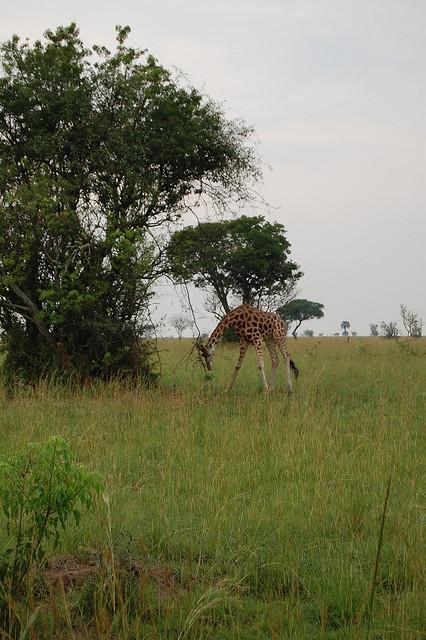What animal is this?
Keep it brief. Giraffe. How many animals can be seen?
Keep it brief. 1. What color is the grass?
Short answer required. Green. Is the giraffe eating?
Answer briefly. Yes. Is this what you would see in a typical American backyard?
Keep it brief. No. What are the giraffes doing?
Quick response, please. Eating. What is the name of the plant in the foreground of the picture?
Answer briefly. Grass. 